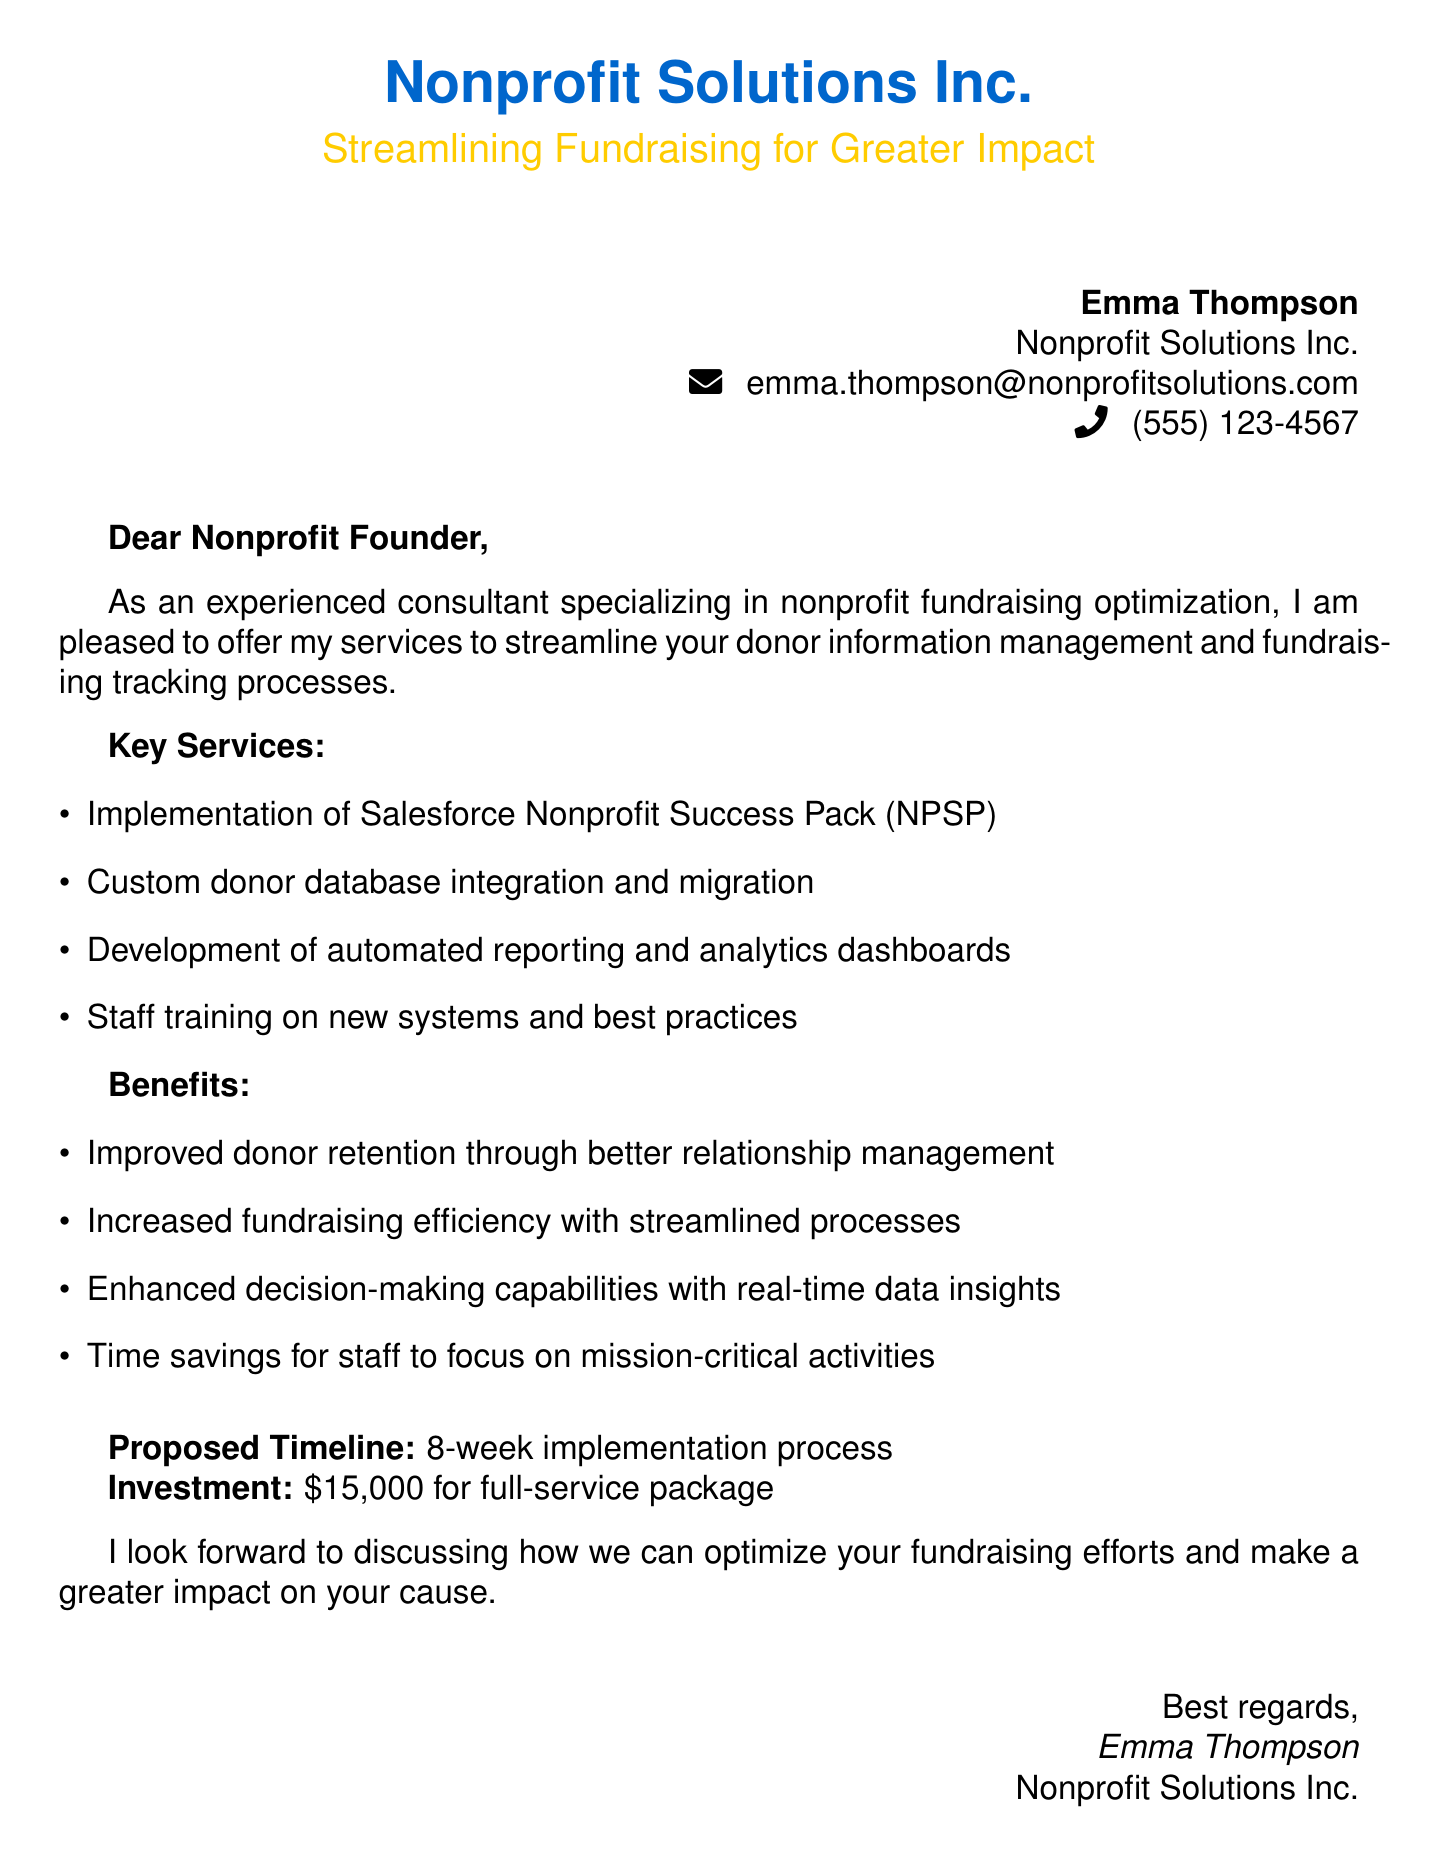What is the name of the consultant? The consultant's name is mentioned at the beginning of the document, which is Emma Thompson.
Answer: Emma Thompson What is the investment amount for the full-service package? The investment is stated clearly in the document as the total cost for the services provided.
Answer: $15,000 What is the proposed timeline for implementation? The document specifies the time required for the implementation process of the services offered.
Answer: 8-week What software will be implemented for donor management? The document mentions a specific software that will be implemented to optimize fundraising tracking processes.
Answer: Salesforce Nonprofit Success Pack (NPSP) What is one benefit of the proposed services? One of the benefits listed in the document highlights an advantage gained from improved systems and processes.
Answer: Improved donor retention What type of document is this? The nature of the document is confirmed by the structured layout and formal communication intended for a nonprofit founder.
Answer: Proposal What is one key service offered in the proposal? The document lists specific services that will be provided to streamline donor management and fundraising tracking.
Answer: Custom donor database integration What is Emma Thompson's email address? The document provides contact information, which includes the consultant's email address for further communication.
Answer: emma.thompson@nonprofitsolutions.com What does the consultant aim to improve through their services? The overarching goal outlined in the document is to enhance a specific aspect of nonprofit operations through their offerings.
Answer: Fundraising efficiency 